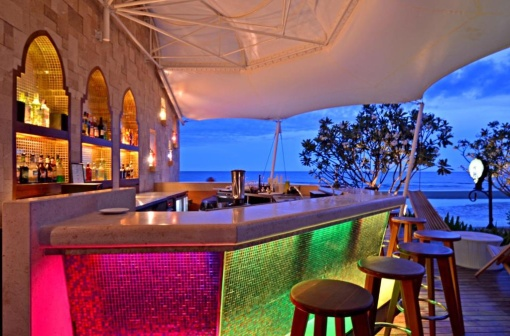What do you think the bar would look like at sunrise? At sunrise, the bar would transform into a serene morning retreat. The soft pink and green lights would be replaced by the gentle, golden hues of dawn, casting a warm glow over the stone structure. The white canopy would appear even brighter against the emerging daylight, creating an inviting space for early birds. The bar stools, still unoccupied, would draw long shadows on the wooden deck. The ocean in the background would reflect the first light of day, shimmering with shades of pink, orange, and gold, adding to the peaceful atmosphere. The tree to the right of the bar would rustle softly in the cool morning breeze, and the white bird sculpture would stand out vividly, illuminated by the rising sun, perfectly complementing the natural beauty of the scene. What kinds of drinks might this bar serve? This beachside bar, with its vibrant and relaxed ambiance, likely serves a variety of refreshing cocktails and beverages. You might find classic beach cocktails like Mojitos, Piña Coladas, and Margaritas, perfectly garnished and chilled to perfection. There would probably be a selection of exotic fruit smoothies and fresh juices, appealing to those looking for non-alcoholic but equally delightful options. Local specialties, possibly infused with tropical fruits and regional flavors, would cater to patrons wanting to savor the essence of the place. You might even encounter a few signature drinks, unique to this bar, creatively crafted by the bartenders to enhance the memorable experience of this scenic spot. 